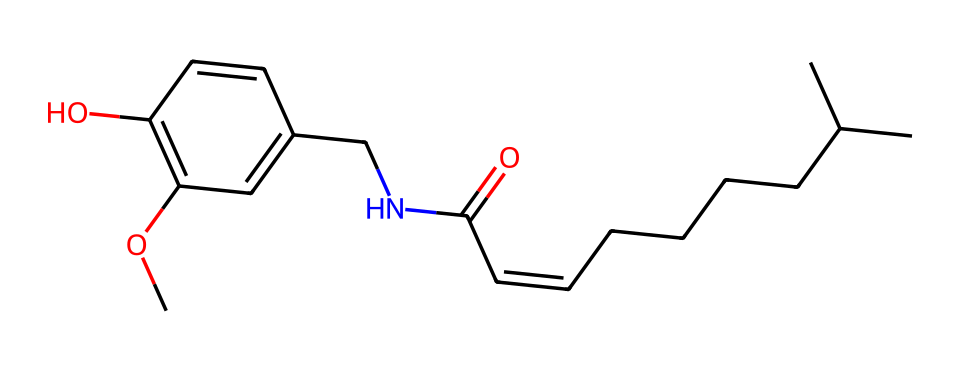What is the main functional group present in this chemical? The chemical structure includes a carbonyl group (C=O) which is characteristic of amides, as well as an ether group (R-O-R'). The carbonyl group is one of the primary functional groups present.
Answer: carbonyl group How many carbon atoms are in this molecule? By counting the carbon (C) atoms in the SMILES representation, there are 15 carbon atoms in total.
Answer: 15 Does this compound contain any heteroatoms? Yes, the chemical contains nitrogen (N) and oxygen (O) atoms, which are considered heteroatoms.
Answer: Yes Is this compound likely to be soluble in water? The presence of polar functional groups, such as the carbonyl and hydroxyl groups, suggests that the compound could have some solubility in water, though the long hydrocarbon chain may reduce overall solubility.
Answer: Somewhat What type of compound is this based on its usage in food? This compound is classified as a food additive because it provides spiciness and flavor, common in culinary applications, particularly in sauces and seasonings.
Answer: food additive Which part contributes to the spiciness of this chemical? The capsaicin molecule has a long hydrophobic tail and a polar functional group, but the specific part contributing to its spiciness is mainly the vanillyl moiety due to its interaction with TRPV1 receptors in the body.
Answer: vanillyl moiety 